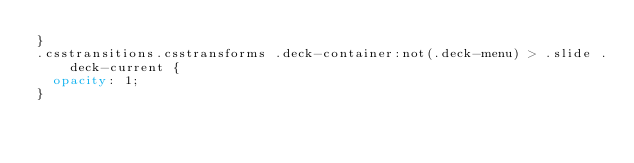Convert code to text. <code><loc_0><loc_0><loc_500><loc_500><_CSS_>}
.csstransitions.csstransforms .deck-container:not(.deck-menu) > .slide .deck-current {
  opacity: 1;
}</code> 